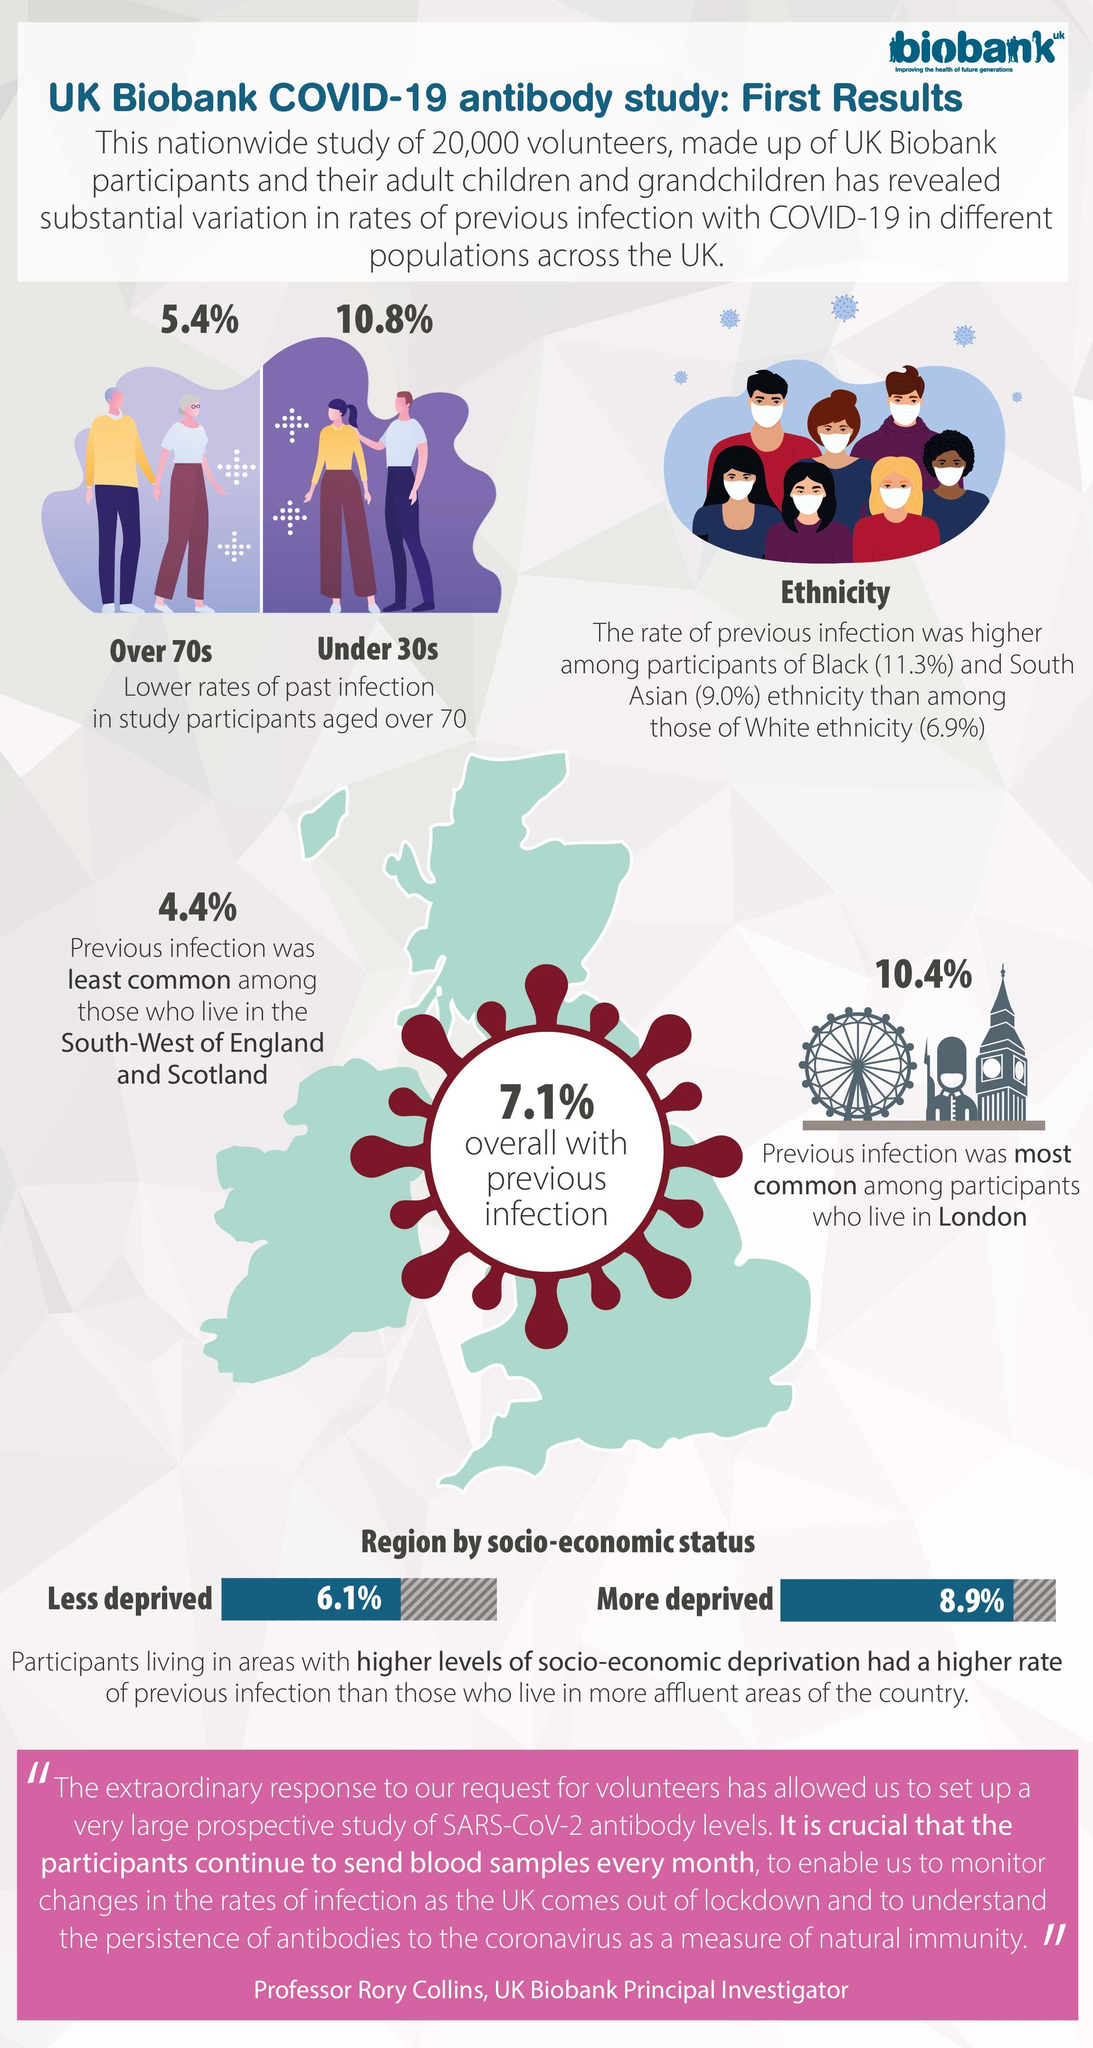Point out several critical features in this image. The least common previous infection was in the South-West of England and Scotland. The rate of past infections in participants over the age of 70 is 5.4%. In the study population of individuals under 30 years old, there has been a history of past infections with a rate of 10.8%. The rate of previous infection among Black participants was higher than that of South Asians by 2.3%. The rate of previous infection for individuals living in affluent areas was 6.1%. 